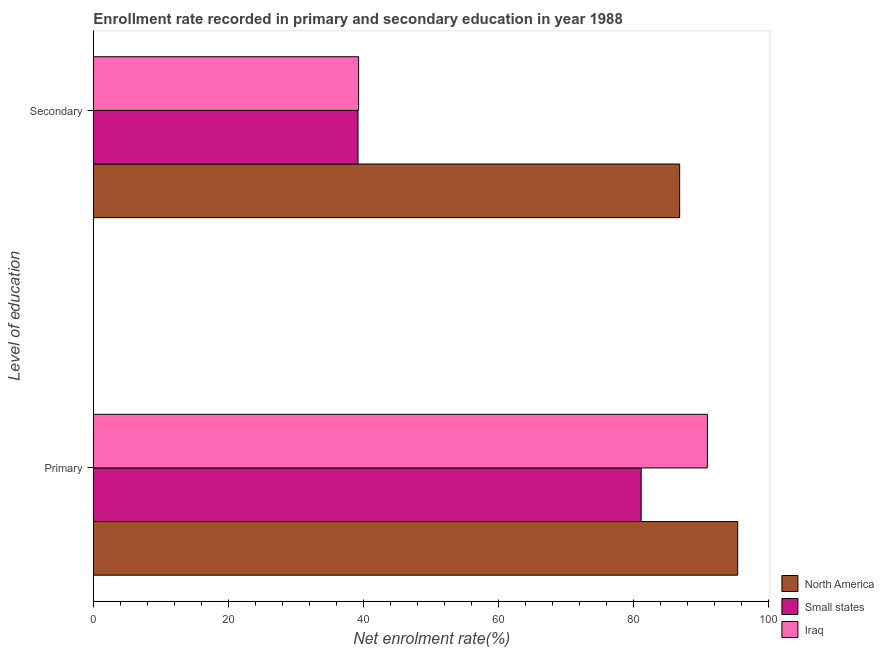How many different coloured bars are there?
Your answer should be very brief. 3. How many bars are there on the 1st tick from the bottom?
Your answer should be very brief. 3. What is the label of the 1st group of bars from the top?
Offer a very short reply. Secondary. What is the enrollment rate in primary education in Iraq?
Provide a short and direct response. 90.89. Across all countries, what is the maximum enrollment rate in secondary education?
Offer a very short reply. 86.79. Across all countries, what is the minimum enrollment rate in primary education?
Keep it short and to the point. 81.08. In which country was the enrollment rate in secondary education maximum?
Provide a succinct answer. North America. In which country was the enrollment rate in secondary education minimum?
Keep it short and to the point. Small states. What is the total enrollment rate in primary education in the graph?
Offer a very short reply. 267.35. What is the difference between the enrollment rate in primary education in Iraq and that in North America?
Your answer should be compact. -4.49. What is the difference between the enrollment rate in primary education in Small states and the enrollment rate in secondary education in North America?
Offer a very short reply. -5.7. What is the average enrollment rate in primary education per country?
Ensure brevity in your answer.  89.12. What is the difference between the enrollment rate in secondary education and enrollment rate in primary education in Small states?
Your response must be concise. -41.92. What is the ratio of the enrollment rate in secondary education in Small states to that in North America?
Provide a short and direct response. 0.45. In how many countries, is the enrollment rate in primary education greater than the average enrollment rate in primary education taken over all countries?
Ensure brevity in your answer.  2. What does the 3rd bar from the top in Secondary represents?
Provide a short and direct response. North America. What does the 3rd bar from the bottom in Primary represents?
Provide a succinct answer. Iraq. How many bars are there?
Keep it short and to the point. 6. Are all the bars in the graph horizontal?
Your response must be concise. Yes. How many countries are there in the graph?
Offer a very short reply. 3. Does the graph contain grids?
Your response must be concise. No. Where does the legend appear in the graph?
Give a very brief answer. Bottom right. How many legend labels are there?
Your response must be concise. 3. What is the title of the graph?
Offer a very short reply. Enrollment rate recorded in primary and secondary education in year 1988. What is the label or title of the X-axis?
Your answer should be compact. Net enrolment rate(%). What is the label or title of the Y-axis?
Make the answer very short. Level of education. What is the Net enrolment rate(%) of North America in Primary?
Offer a terse response. 95.38. What is the Net enrolment rate(%) of Small states in Primary?
Offer a terse response. 81.08. What is the Net enrolment rate(%) of Iraq in Primary?
Give a very brief answer. 90.89. What is the Net enrolment rate(%) in North America in Secondary?
Offer a very short reply. 86.79. What is the Net enrolment rate(%) in Small states in Secondary?
Provide a succinct answer. 39.17. What is the Net enrolment rate(%) of Iraq in Secondary?
Your response must be concise. 39.25. Across all Level of education, what is the maximum Net enrolment rate(%) in North America?
Ensure brevity in your answer.  95.38. Across all Level of education, what is the maximum Net enrolment rate(%) in Small states?
Offer a very short reply. 81.08. Across all Level of education, what is the maximum Net enrolment rate(%) in Iraq?
Your response must be concise. 90.89. Across all Level of education, what is the minimum Net enrolment rate(%) in North America?
Your answer should be compact. 86.79. Across all Level of education, what is the minimum Net enrolment rate(%) of Small states?
Your answer should be compact. 39.17. Across all Level of education, what is the minimum Net enrolment rate(%) of Iraq?
Give a very brief answer. 39.25. What is the total Net enrolment rate(%) in North America in the graph?
Make the answer very short. 182.16. What is the total Net enrolment rate(%) of Small states in the graph?
Offer a very short reply. 120.25. What is the total Net enrolment rate(%) of Iraq in the graph?
Your response must be concise. 130.14. What is the difference between the Net enrolment rate(%) in North America in Primary and that in Secondary?
Keep it short and to the point. 8.59. What is the difference between the Net enrolment rate(%) of Small states in Primary and that in Secondary?
Ensure brevity in your answer.  41.92. What is the difference between the Net enrolment rate(%) of Iraq in Primary and that in Secondary?
Your response must be concise. 51.63. What is the difference between the Net enrolment rate(%) in North America in Primary and the Net enrolment rate(%) in Small states in Secondary?
Give a very brief answer. 56.21. What is the difference between the Net enrolment rate(%) in North America in Primary and the Net enrolment rate(%) in Iraq in Secondary?
Give a very brief answer. 56.13. What is the difference between the Net enrolment rate(%) in Small states in Primary and the Net enrolment rate(%) in Iraq in Secondary?
Keep it short and to the point. 41.83. What is the average Net enrolment rate(%) in North America per Level of education?
Your response must be concise. 91.08. What is the average Net enrolment rate(%) in Small states per Level of education?
Offer a very short reply. 60.13. What is the average Net enrolment rate(%) in Iraq per Level of education?
Offer a very short reply. 65.07. What is the difference between the Net enrolment rate(%) of North America and Net enrolment rate(%) of Small states in Primary?
Offer a very short reply. 14.29. What is the difference between the Net enrolment rate(%) in North America and Net enrolment rate(%) in Iraq in Primary?
Offer a very short reply. 4.49. What is the difference between the Net enrolment rate(%) of Small states and Net enrolment rate(%) of Iraq in Primary?
Provide a succinct answer. -9.8. What is the difference between the Net enrolment rate(%) in North America and Net enrolment rate(%) in Small states in Secondary?
Provide a short and direct response. 47.62. What is the difference between the Net enrolment rate(%) of North America and Net enrolment rate(%) of Iraq in Secondary?
Keep it short and to the point. 47.53. What is the difference between the Net enrolment rate(%) of Small states and Net enrolment rate(%) of Iraq in Secondary?
Ensure brevity in your answer.  -0.09. What is the ratio of the Net enrolment rate(%) in North America in Primary to that in Secondary?
Make the answer very short. 1.1. What is the ratio of the Net enrolment rate(%) in Small states in Primary to that in Secondary?
Your answer should be very brief. 2.07. What is the ratio of the Net enrolment rate(%) of Iraq in Primary to that in Secondary?
Keep it short and to the point. 2.32. What is the difference between the highest and the second highest Net enrolment rate(%) in North America?
Provide a short and direct response. 8.59. What is the difference between the highest and the second highest Net enrolment rate(%) of Small states?
Offer a terse response. 41.92. What is the difference between the highest and the second highest Net enrolment rate(%) of Iraq?
Make the answer very short. 51.63. What is the difference between the highest and the lowest Net enrolment rate(%) of North America?
Offer a terse response. 8.59. What is the difference between the highest and the lowest Net enrolment rate(%) of Small states?
Ensure brevity in your answer.  41.92. What is the difference between the highest and the lowest Net enrolment rate(%) in Iraq?
Make the answer very short. 51.63. 